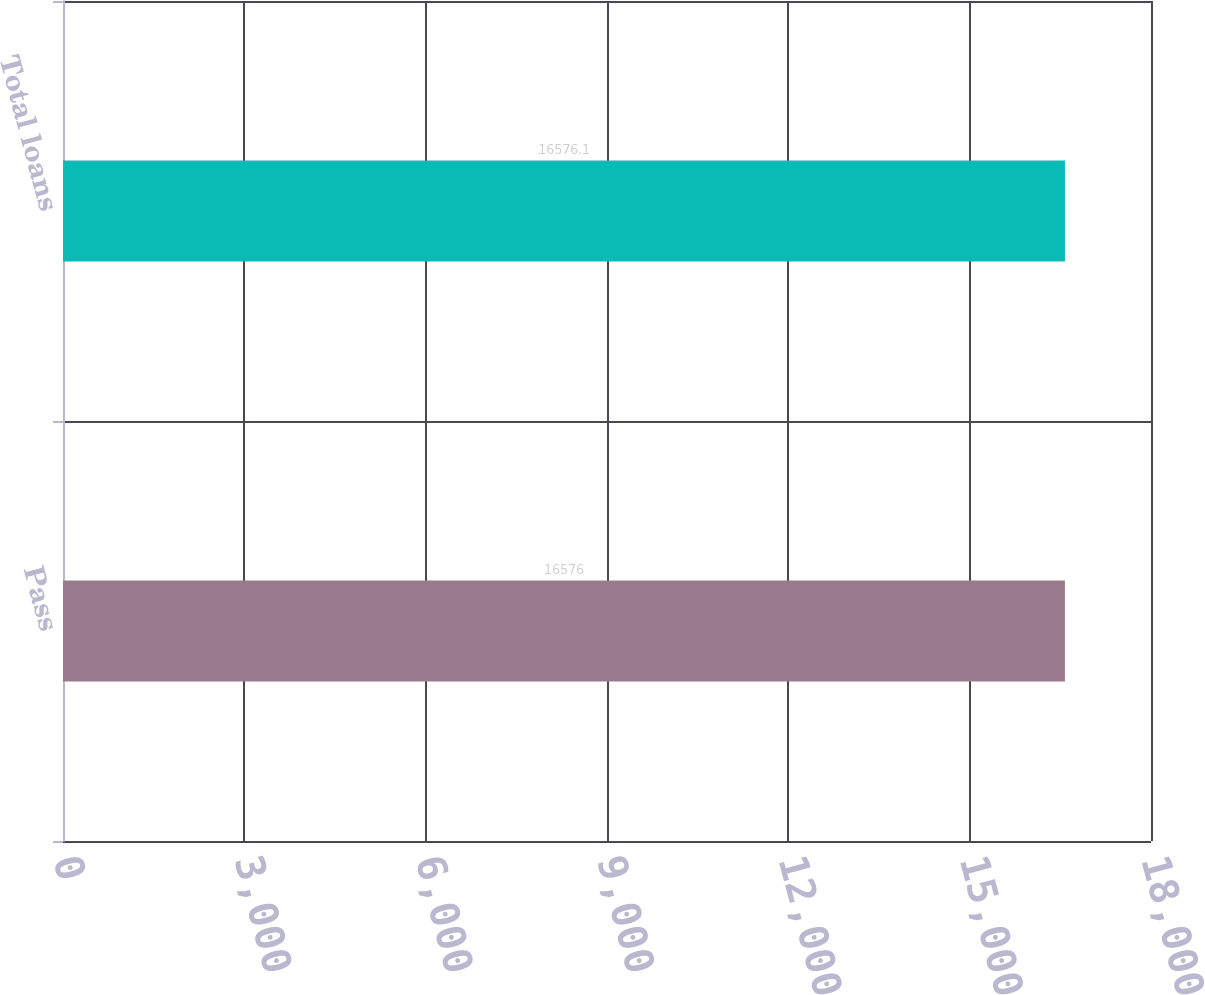Convert chart. <chart><loc_0><loc_0><loc_500><loc_500><bar_chart><fcel>Pass<fcel>Total loans<nl><fcel>16576<fcel>16576.1<nl></chart> 